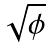Convert formula to latex. <formula><loc_0><loc_0><loc_500><loc_500>\sqrt { \phi }</formula> 